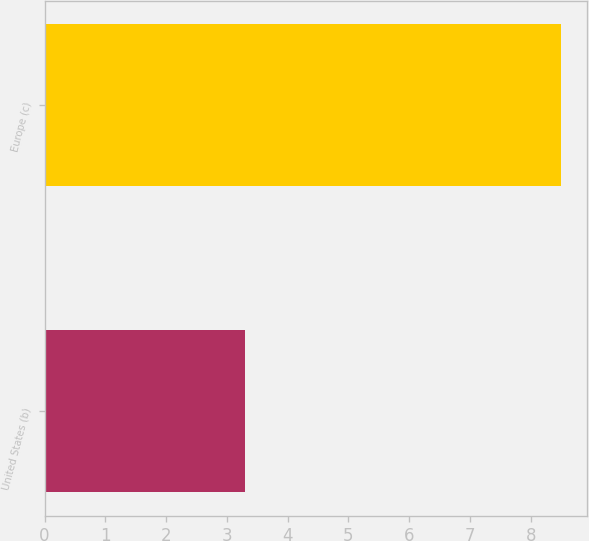Convert chart to OTSL. <chart><loc_0><loc_0><loc_500><loc_500><bar_chart><fcel>United States (b)<fcel>Europe (c)<nl><fcel>3.3<fcel>8.5<nl></chart> 